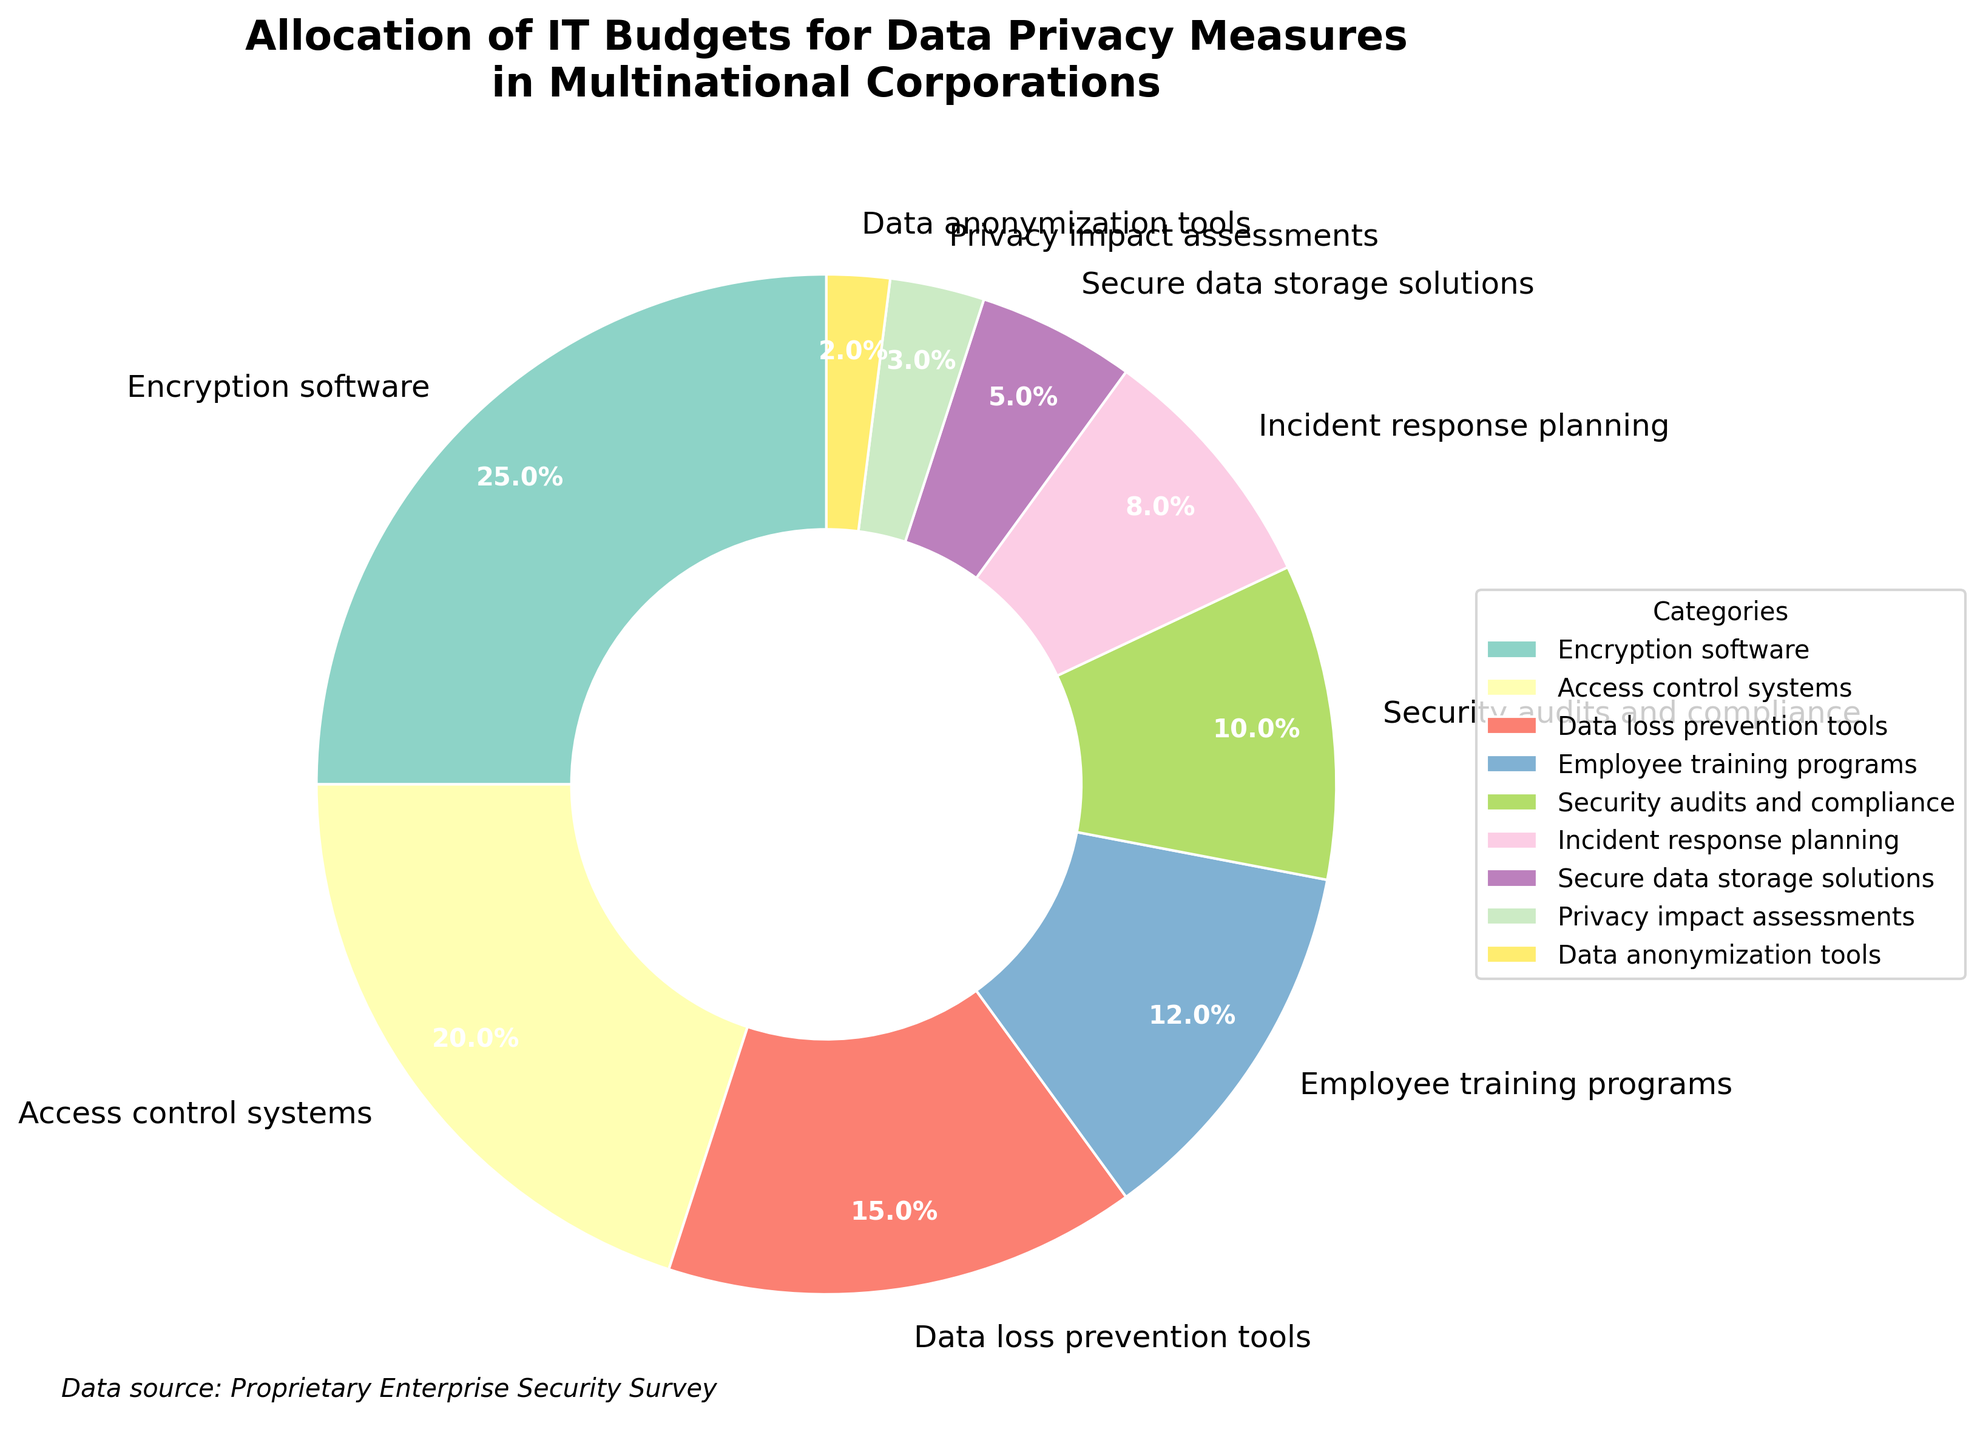What category receives the highest allocation of IT budgets for data privacy measures? Identify the category with the largest percentage slice. The "Encryption software" category has the largest slice.
Answer: Encryption software Which two categories combined account for the largest share of the IT budget? Find the two categories with the highest individual percentages and sum them: Encryption software (25%) + Access control systems (20%) = 45%.
Answer: Encryption software and Access control systems What is the total percentage allocated to proactive measures (Employee training programs, Security audits and compliance, Incident response planning)? Sum the percentages for these categories: Employee training programs (12%) + Security audits and compliance (10%) + Incident response planning (8%) = 30%.
Answer: 30% Compare the allocation for Data anonymization tools with Secure data storage solutions. Which one is higher, and by how much? Data anonymization tools (2%) vs. Secure data storage solutions (5%); Secure data storage solutions has 3% more allocation.
Answer: Secure data storage solutions, by 3% How much more budget is allocated to Access control systems compared to Data loss prevention tools? Subtract the percentage for Data loss prevention tools from Access control systems: 20% - 15% = 5%.
Answer: 5% What percentage of the IT budget is allocated to Encryption software and Access control systems together? Add the percentages for Encryption software and Access control systems: 25% + 20% = 45%.
Answer: 45% Which category has the smallest allocation, and what is its percentage? Identify the smallest percentage slice which belongs to Data anonymization tools (2%).
Answer: Data anonymization tools, 2% What is the difference in allocation between Employee training programs and Security audits and compliance? Subtract the percentage for Security audits and compliance from Employee training programs: 12% - 10% = 2%.
Answer: 2% Is the budget for Incident response planning greater than or less than that for Security audits and compliance? Compare the percentages for Incident response planning (8%) and Security audits and compliance (10%) and determine which is larger.
Answer: Less Looking at the visual distribution, what can you say about the overall emphasis of IT budgets for data privacy measures? Visually, the chart shows that more significant portions of the budget are allocated to Encryption software and Access control systems, suggesting a focus on software and systems-based solutions.
Answer: Emphasis on software and systems-based solutions 